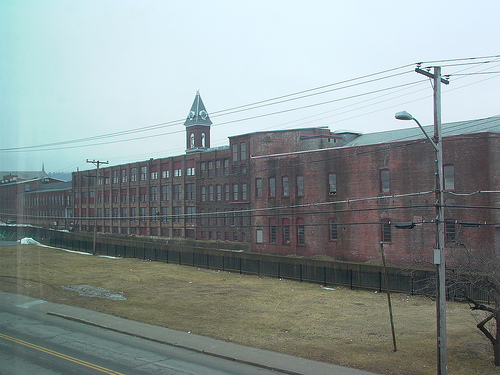<image>
Can you confirm if the telephone pole is on the fence? No. The telephone pole is not positioned on the fence. They may be near each other, but the telephone pole is not supported by or resting on top of the fence. 